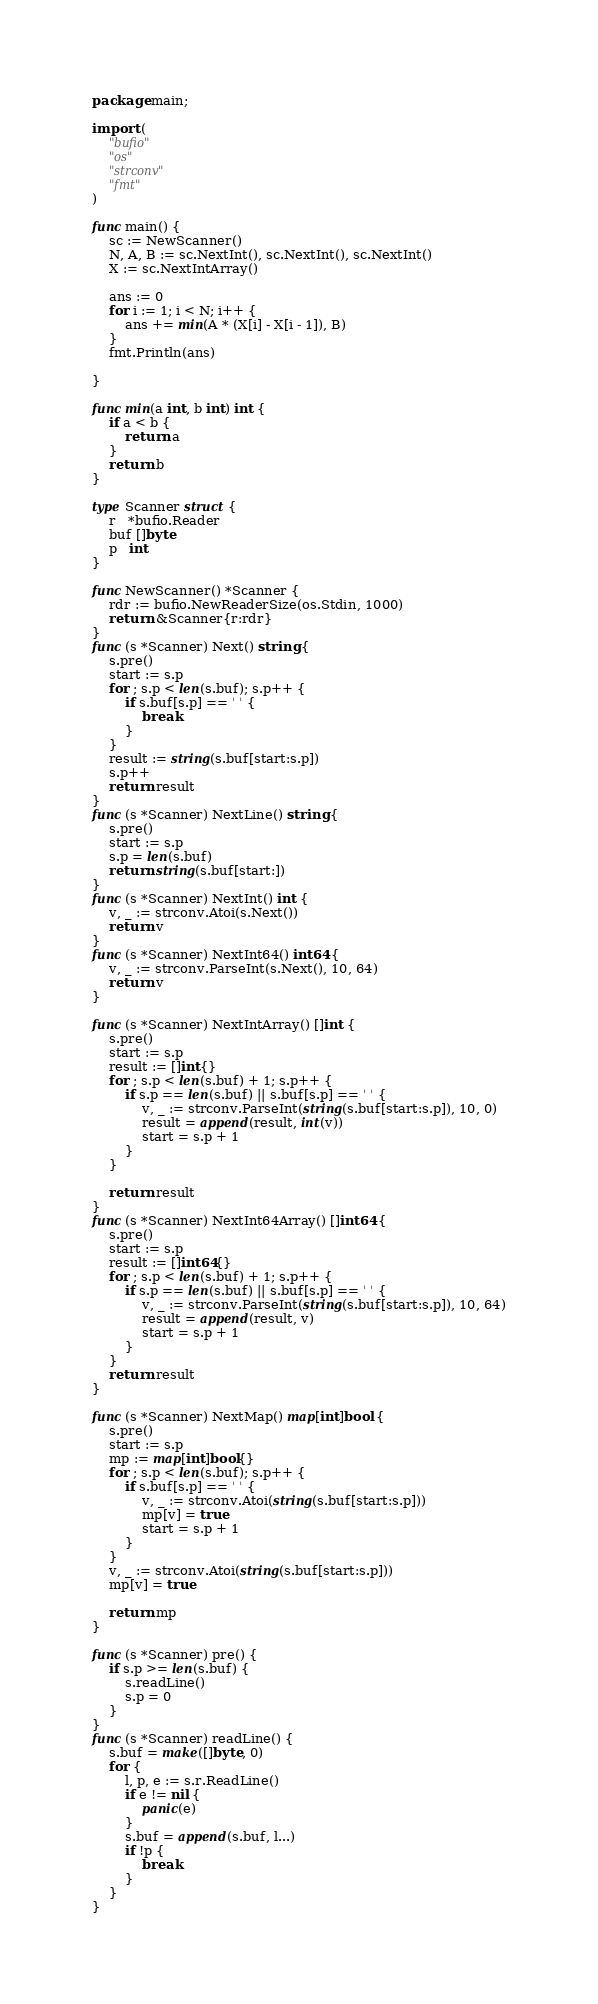Convert code to text. <code><loc_0><loc_0><loc_500><loc_500><_Go_>package main;

import (
	"bufio"
	"os"
	"strconv"
	"fmt"
)

func main() {
	sc := NewScanner()
	N, A, B := sc.NextInt(), sc.NextInt(), sc.NextInt()
	X := sc.NextIntArray()

	ans := 0
	for i := 1; i < N; i++ {
		ans += min(A * (X[i] - X[i - 1]), B)
	}
	fmt.Println(ans)

}

func min(a int, b int) int {
	if a < b {
		return a
	}
	return b
}

type Scanner struct {
	r   *bufio.Reader
	buf []byte
	p   int
}

func NewScanner() *Scanner {
	rdr := bufio.NewReaderSize(os.Stdin, 1000)
	return &Scanner{r:rdr}
}
func (s *Scanner) Next() string {
	s.pre()
	start := s.p
	for ; s.p < len(s.buf); s.p++ {
		if s.buf[s.p] == ' ' {
			break
		}
	}
	result := string(s.buf[start:s.p])
	s.p++
	return result
}
func (s *Scanner) NextLine() string {
	s.pre()
	start := s.p
	s.p = len(s.buf)
	return string(s.buf[start:])
}
func (s *Scanner) NextInt() int {
	v, _ := strconv.Atoi(s.Next())
	return v
}
func (s *Scanner) NextInt64() int64 {
	v, _ := strconv.ParseInt(s.Next(), 10, 64)
	return v
}

func (s *Scanner) NextIntArray() []int {
	s.pre()
	start := s.p
	result := []int{}
	for ; s.p < len(s.buf) + 1; s.p++ {
		if s.p == len(s.buf) || s.buf[s.p] == ' ' {
			v, _ := strconv.ParseInt(string(s.buf[start:s.p]), 10, 0)
			result = append(result, int(v))
			start = s.p + 1
		}
	}

	return result
}
func (s *Scanner) NextInt64Array() []int64 {
	s.pre()
	start := s.p
	result := []int64{}
	for ; s.p < len(s.buf) + 1; s.p++ {
		if s.p == len(s.buf) || s.buf[s.p] == ' ' {
			v, _ := strconv.ParseInt(string(s.buf[start:s.p]), 10, 64)
			result = append(result, v)
			start = s.p + 1
		}
	}
	return result
}

func (s *Scanner) NextMap() map[int]bool {
	s.pre()
	start := s.p
	mp := map[int]bool{}
	for ; s.p < len(s.buf); s.p++ {
		if s.buf[s.p] == ' ' {
			v, _ := strconv.Atoi(string(s.buf[start:s.p]))
			mp[v] = true
			start = s.p + 1
		}
	}
	v, _ := strconv.Atoi(string(s.buf[start:s.p]))
	mp[v] = true

	return mp
}

func (s *Scanner) pre() {
	if s.p >= len(s.buf) {
		s.readLine()
		s.p = 0
	}
}
func (s *Scanner) readLine() {
	s.buf = make([]byte, 0)
	for {
		l, p, e := s.r.ReadLine()
		if e != nil {
			panic(e)
		}
		s.buf = append(s.buf, l...)
		if !p {
			break
		}
	}
}
</code> 